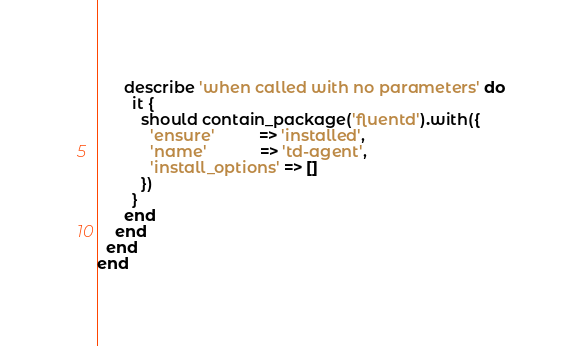<code> <loc_0><loc_0><loc_500><loc_500><_Ruby_>      describe 'when called with no parameters' do
        it {
          should contain_package('fluentd').with({
            'ensure'          => 'installed',
            'name'            => 'td-agent',
            'install_options' => []
          })
        }
      end
    end
  end
end
</code> 